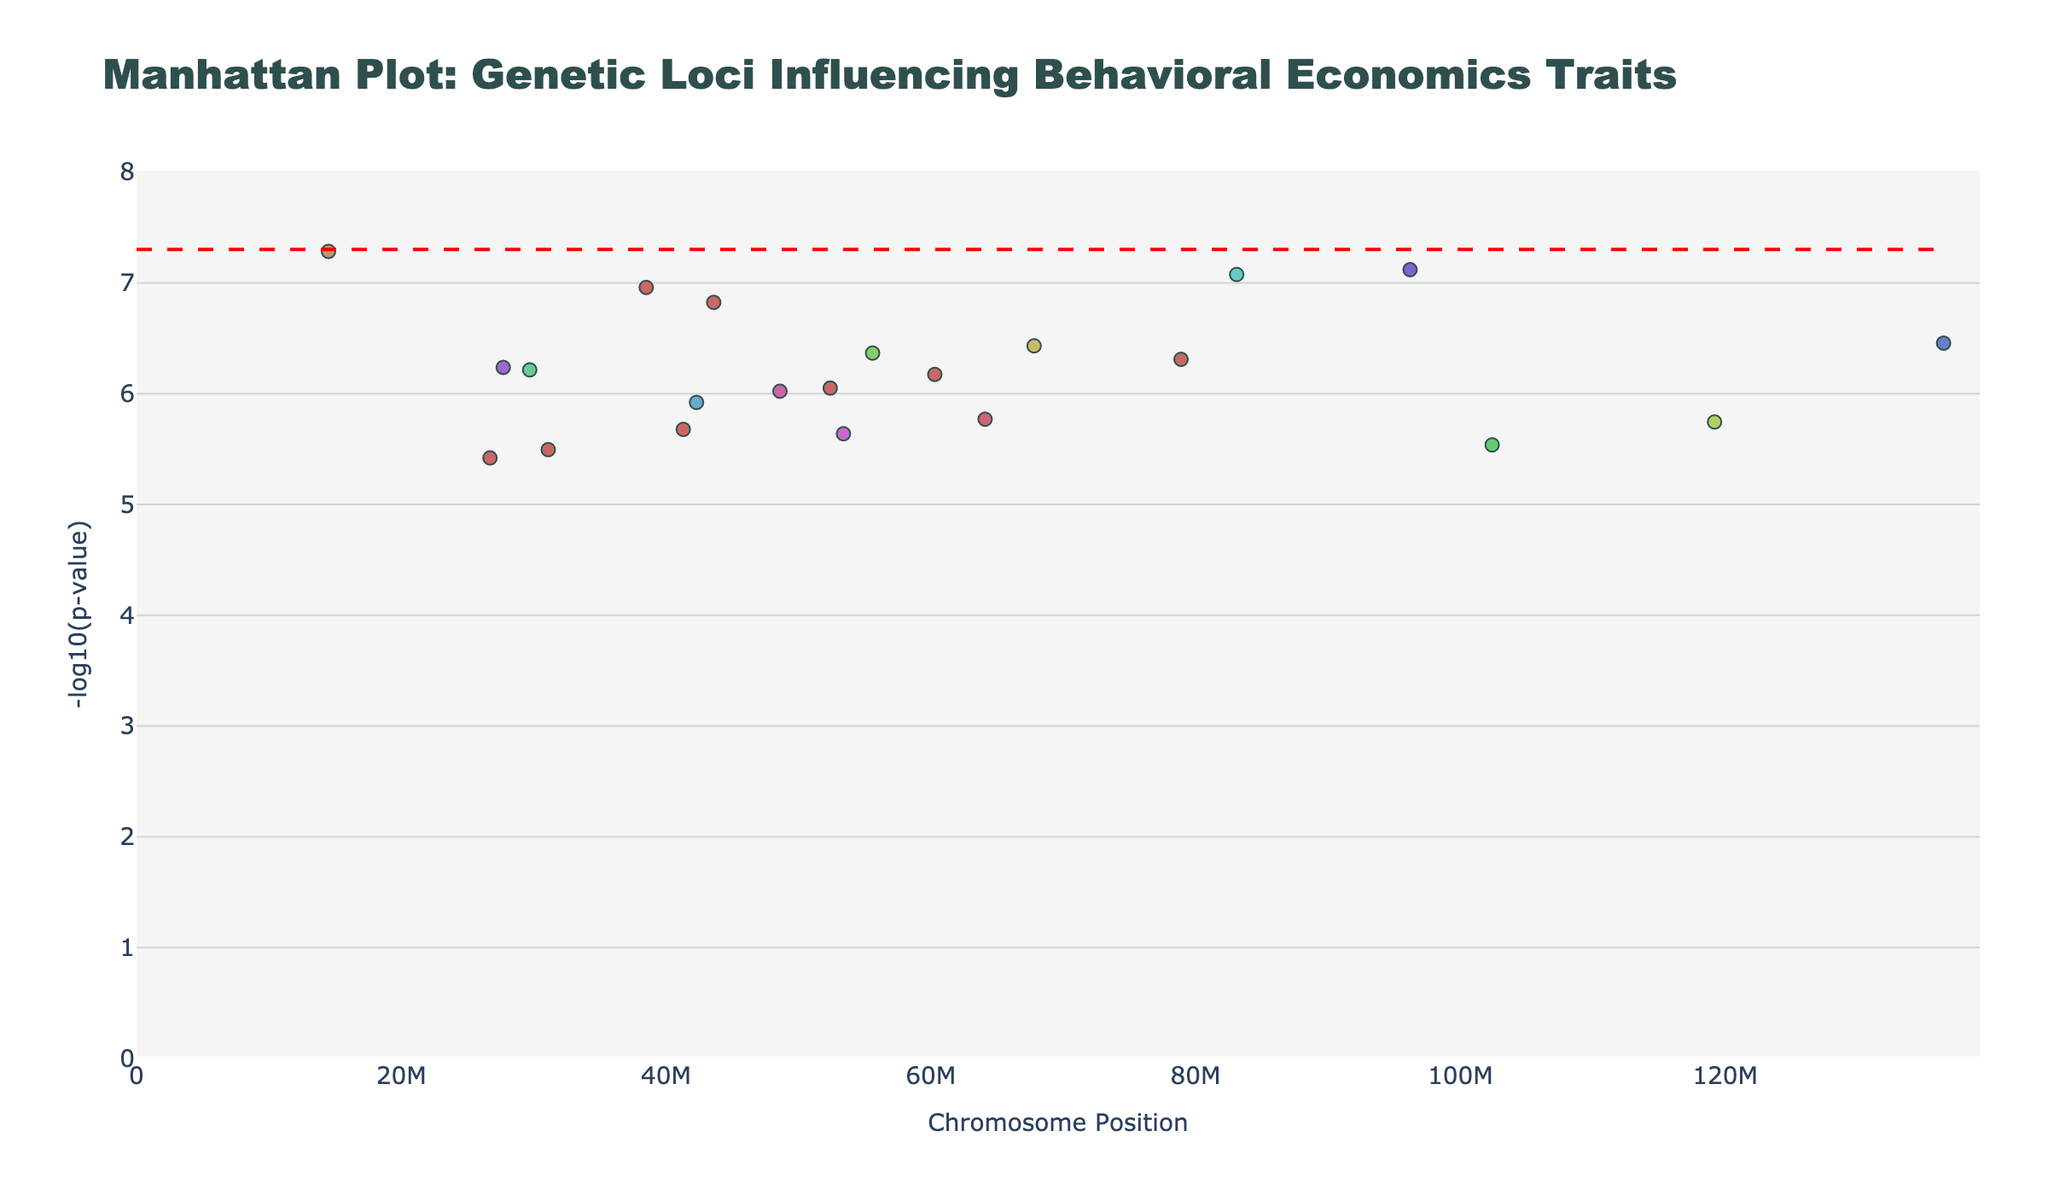Which chromosomal locus exhibits the most significant association with a behavioral trait? To find the most significant association, locate the point with the highest -log10(p-value) on the y-axis. This corresponds to the lowest p-value. The gene SLC6A4 on Chromosome 17 for "Anxiety in Trading" has the highest -log10(p) value, approximately 7.82.
Answer: SLC6A4 on Chromosome 17 How many unique chromosomes have significant loci below the threshold line? To determine this, count the number of unique chromosomes that have at least one point below the threshold line of -log10(5e-8).
Answer: 13 chromosomes What is the range of -log10(p-values) shown on the y-axis? Examine the y-axis to identify the minimum and maximum values displayed. The range starts at 0 and goes up to slightly above 7.82.
Answer: 0 to 7.82 Which trait is associated with the gene ANKK1 and on which chromosome is it located? Identify the gene ANKK1 in the plot. Hovering over the point or analyzing the data reveals that ANKK1 is associated with "Asset Allocation Preference" and is located on Chromosome 10.
Answer: Asset Allocation Preference on Chromosome 10 Are there any chromosomes that contain significant loci for more than one behavioral trait? Observe the data to identify any chromosomes that have multiple points below the significance threshold (-log10(5e-8)). Chromosome 4 (BDNF) and Chromosome 22 (COMT) appear to have two different traits each.
Answer: Yes, Chromosomes 4 and 22 What is the gene and associated p-value for the behavioral trait "Risk Tolerance"? Find the location of the behavioral trait "Risk Tolerance" in the plot. The gene associated with "Risk Tolerance" is FOXO3 on Chromosome 1 with a p-value corresponding to -log10(5.2e-8)≈ 7.28.
Answer: FOXO3 with p-value 5.2e-8 Which gene and associated behavioral trait have the second-lowest p-value in the plot? Identify the point with the second-highest -log10(p) next to the highest point (SLC6A4 for "Anxiety in Trading"). The gene is COMT for the trait "Emotional Regulation" with a p-value corresponding to -log10(1.1e-7) ≈ 6.96.
Answer: COMT for Emotional Regulation 